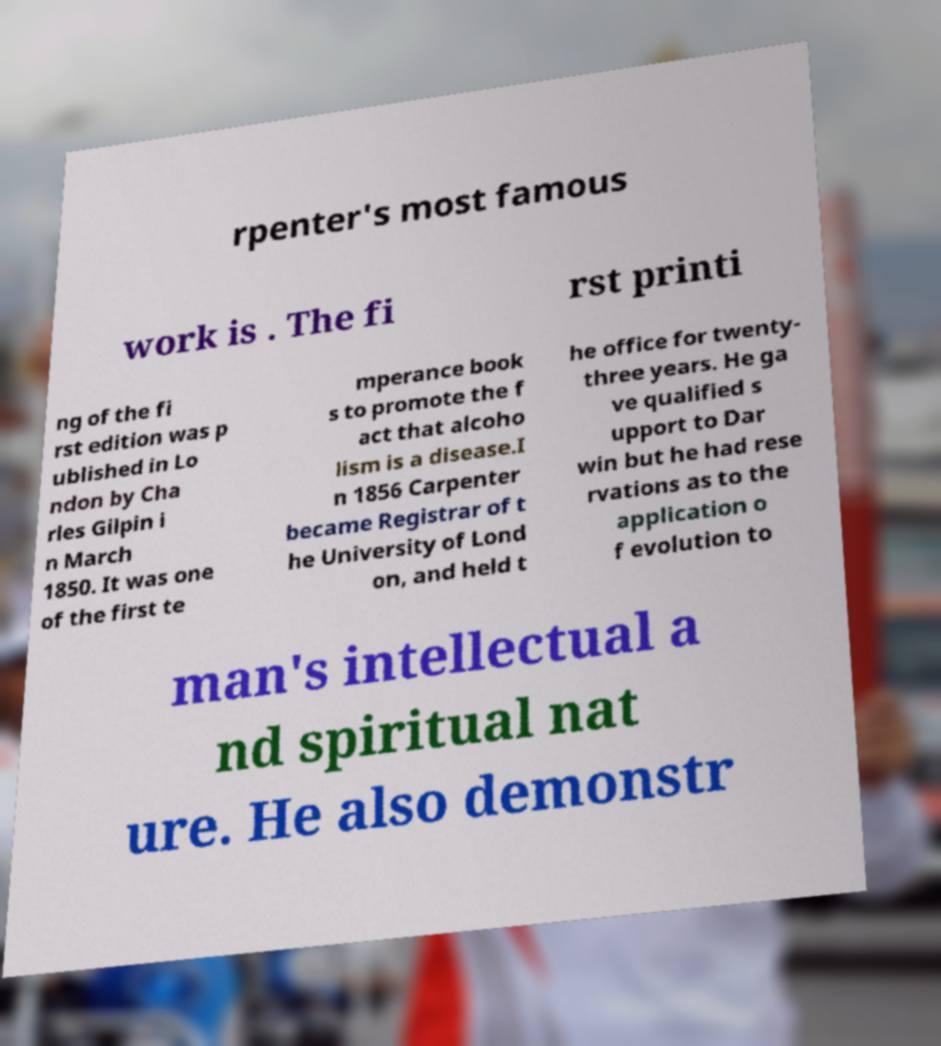Please read and relay the text visible in this image. What does it say? rpenter's most famous work is . The fi rst printi ng of the fi rst edition was p ublished in Lo ndon by Cha rles Gilpin i n March 1850. It was one of the first te mperance book s to promote the f act that alcoho lism is a disease.I n 1856 Carpenter became Registrar of t he University of Lond on, and held t he office for twenty- three years. He ga ve qualified s upport to Dar win but he had rese rvations as to the application o f evolution to man's intellectual a nd spiritual nat ure. He also demonstr 